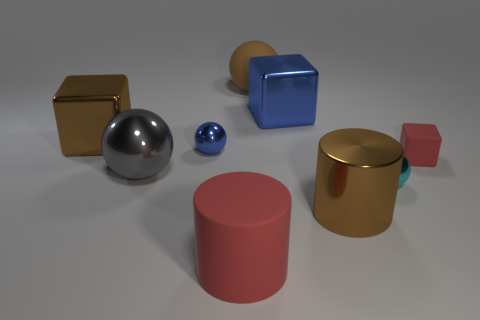Add 1 tiny blue shiny things. How many objects exist? 10 Subtract all cubes. How many objects are left? 6 Subtract all tiny blue metallic spheres. Subtract all blue shiny cubes. How many objects are left? 7 Add 7 blue spheres. How many blue spheres are left? 8 Add 3 small green matte cubes. How many small green matte cubes exist? 3 Subtract 1 gray balls. How many objects are left? 8 